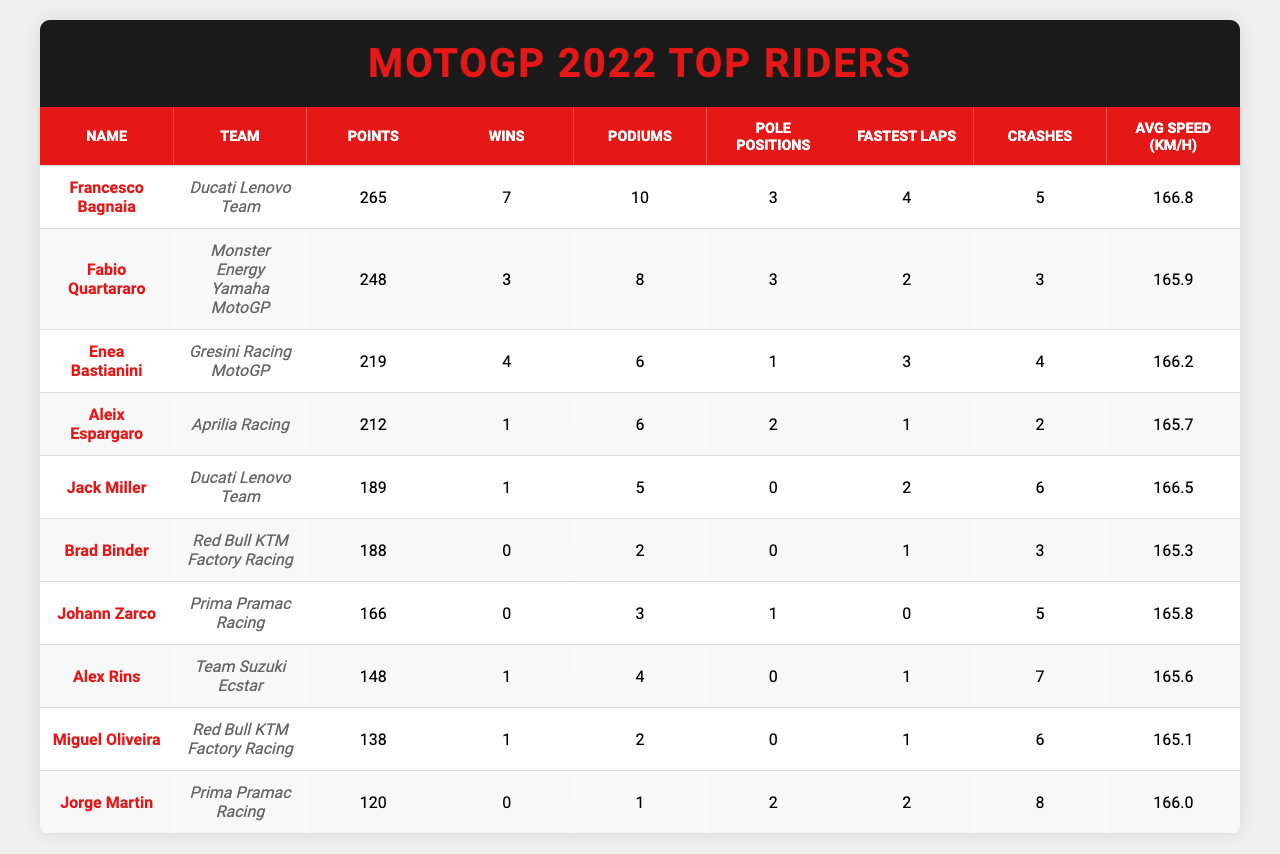What is the highest number of points scored by a rider? Francesco Bagnaia has the highest points with a total of 265, which can be found in the "Points" column of the table.
Answer: 265 Who had the most wins in the 2022 season? Francesco Bagnaia had the most wins, with a total of 7, as indicated in the "Wins" column.
Answer: 7 How many podiums did Fabio Quartararo achieve? Fabio Quartararo achieved 8 podiums, as shown in the "Podiums" column next to his name.
Answer: 8 Did any rider complete a season without a win? Yes, both Brad Binder and Johann Zarco did not win any races, as their "Wins" column shows 0.
Answer: Yes What is the average speed of Enea Bastianini? Enea Bastianini's average speed is 166.2 km/h, which is listed in the "Avg Speed (km/h)" column.
Answer: 166.2 km/h How many total wins did the top three riders accumulate? The top three riders: Bagnaia (7), Quartararo (3), and Bastianini (4) have a total of 7 + 3 + 4 = 14 wins combined.
Answer: 14 Which rider had the fewest crashes? Aleix Espargaro had the fewest crashes with 2, as found in the "Crashes" column.
Answer: 2 What is the difference in points between the first and second-ranked riders? The difference is 265 (Bagnaia) - 248 (Quartararo) = 17 points.
Answer: 17 Who had the highest average speed among the top 10 riders? Francesco Bagnaia had the highest average speed at 166.8 km/h, which appears in the "Avg Speed (km/h)" column.
Answer: 166.8 km/h How many riders scored more than 200 points? Four riders scored more than 200 points: Bagnaia (265), Quartararo (248), Bastianini (219), and Espargaro (212).
Answer: 4 